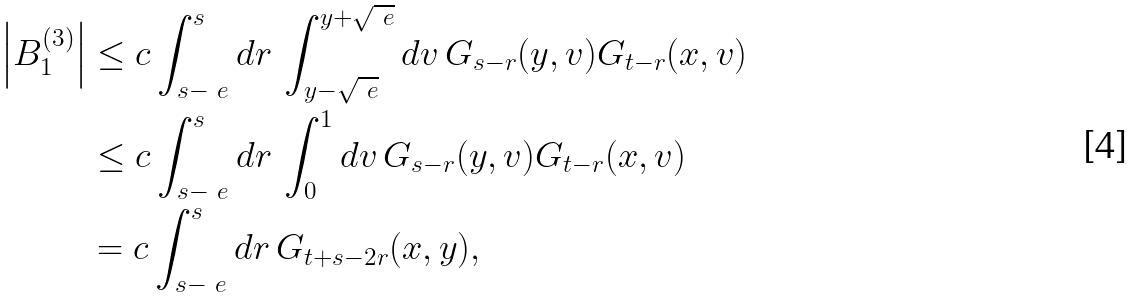<formula> <loc_0><loc_0><loc_500><loc_500>\left | B _ { 1 } ^ { ( 3 ) } \right | & \leq c \int _ { s - \ e } ^ { s } d r \, \int _ { y - \sqrt { \ e } } ^ { y + \sqrt { \ e } } d v \, G _ { s - r } ( y , v ) G _ { t - r } ( x , v ) \\ & \leq c \int _ { s - \ e } ^ { s } d r \, \int _ { 0 } ^ { 1 } d v \, G _ { s - r } ( y , v ) G _ { t - r } ( x , v ) \\ & = c \int _ { s - \ e } ^ { s } d r \, G _ { t + s - 2 r } ( x , y ) ,</formula> 